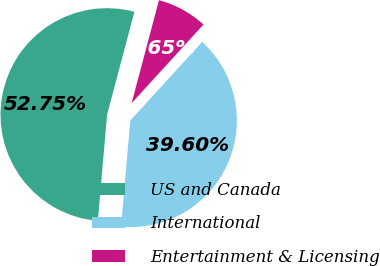Convert chart to OTSL. <chart><loc_0><loc_0><loc_500><loc_500><pie_chart><fcel>US and Canada<fcel>International<fcel>Entertainment & Licensing<nl><fcel>52.75%<fcel>39.6%<fcel>7.65%<nl></chart> 